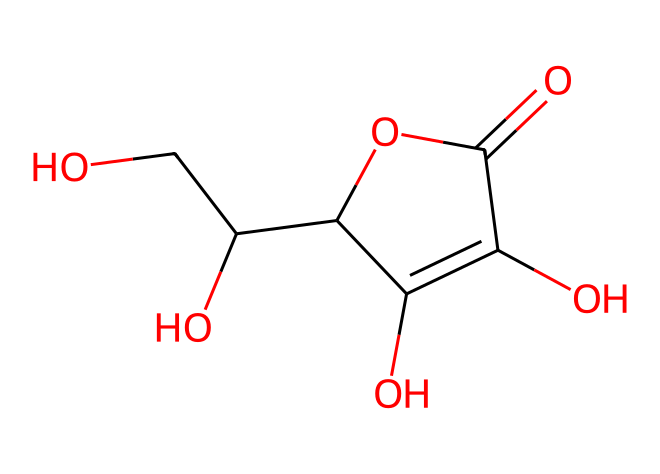How many carbon atoms are present in vitamin C? The SMILES representation indicates the structure of ascorbic acid, which includes multiple segments of carbon atoms denoted by 'C'. Counting each 'C' in the representation, we find there are 6 carbon atoms total.
Answer: 6 What type of functional group does vitamin C possess due to the presence of -OH groups? The presence of multiple -OH (hydroxyl) groups in the structure characterizes it as a polyol or sugar alcohol. Each -OH group allows for hydrogen bonding, impacting its solubility in water.
Answer: polyol What is the molecular formula of vitamin C? By analyzing the structure, we can derive the molecular formula from the number of atoms observed. There are 6 carbon atoms, 8 hydrogen atoms, and 6 oxygen atoms in total, leading to the molecular formula C6H8O6.
Answer: C6H8O6 How many double bonds are visible in the chemical structure of vitamin C? Inspecting the structural representation, there is one double bond seen between carbon atoms and one between a carbon atom and an oxygen atom in the -C(=O)- part of the molecule. Thus, there is a total of 2 double bonds.
Answer: 2 What is the significance of the carboxylic acid group in vitamin C? The carboxylic acid group (-COOH) in vitamin C contributes to its acidic nature and plays a crucial role in its antioxidant properties. This functionality allows vitamin C to donate electrons and neutralize free radicals.
Answer: antioxidant properties Is vitamin C hydrophilic or hydrophobic? The presence of multiple -OH (hydroxyl) groups in the structure makes vitamin C highly hydrophilic. These hydroxyl groups form hydrogen bonds with water, resulting in high solubility.
Answer: hydrophilic 